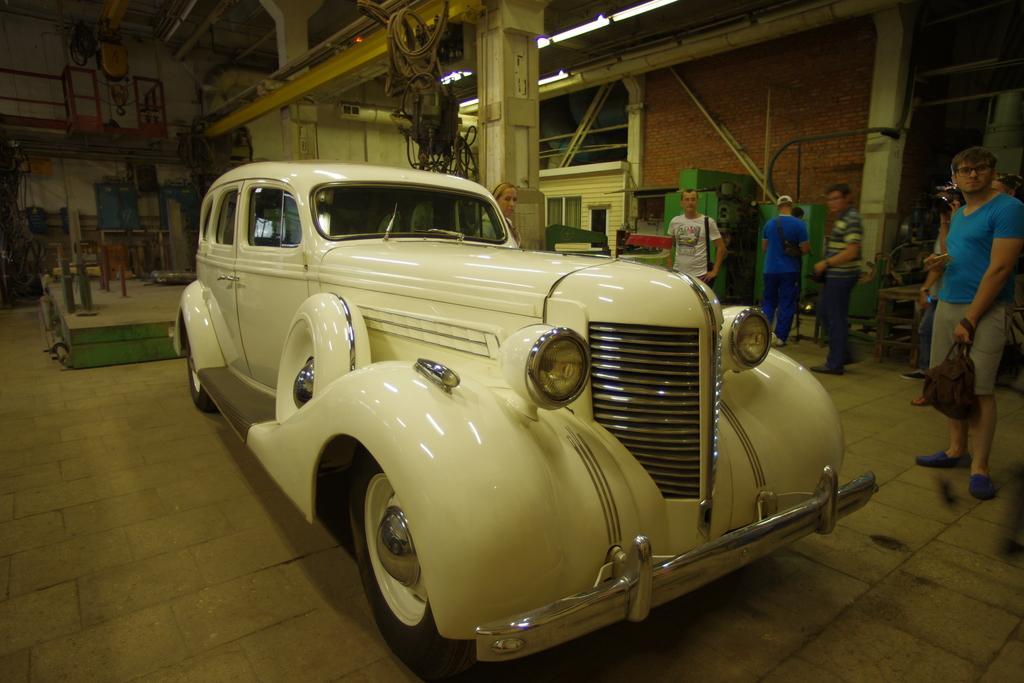In one or two sentences, can you explain what this image depicts? In this image we can see some people and there is a vehicle which is in white color and there are some objects in the room and we can see some lights attached to the ceiling. 